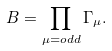Convert formula to latex. <formula><loc_0><loc_0><loc_500><loc_500>B = \prod _ { \mu = o d d } \Gamma _ { \mu } .</formula> 